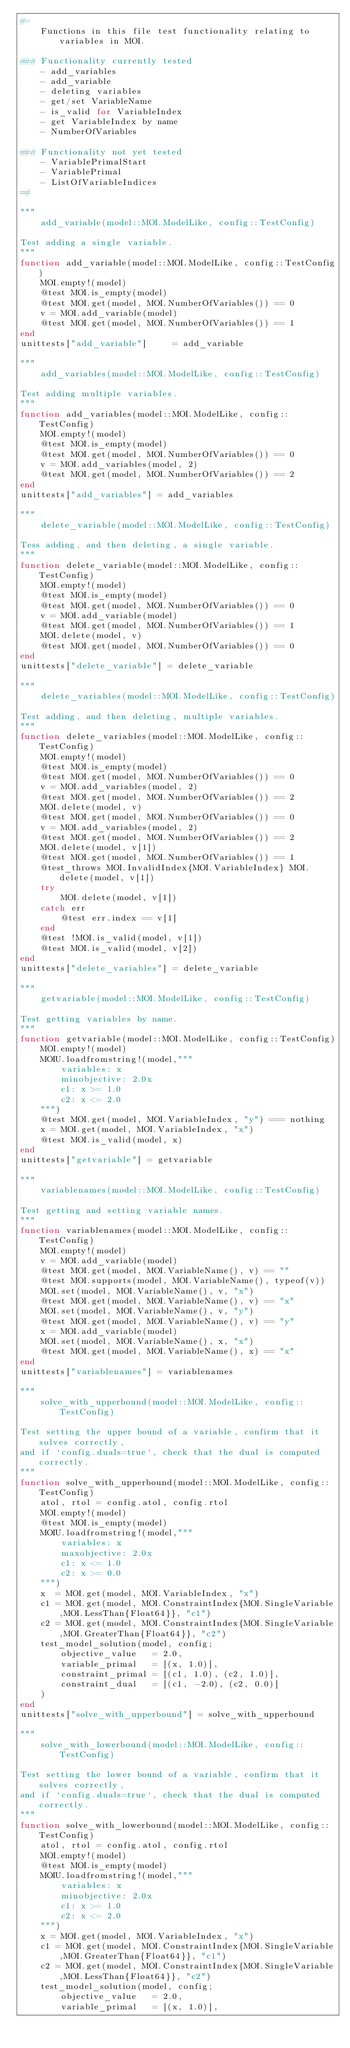Convert code to text. <code><loc_0><loc_0><loc_500><loc_500><_Julia_>#=
    Functions in this file test functionality relating to variables in MOI.

### Functionality currently tested
    - add_variables
    - add_variable
    - deleting variables
    - get/set VariableName
    - is_valid for VariableIndex
    - get VariableIndex by name
    - NumberOfVariables

### Functionality not yet tested
    - VariablePrimalStart
    - VariablePrimal
    - ListOfVariableIndices
=#

"""
    add_variable(model::MOI.ModelLike, config::TestConfig)

Test adding a single variable.
"""
function add_variable(model::MOI.ModelLike, config::TestConfig)
    MOI.empty!(model)
    @test MOI.is_empty(model)
    @test MOI.get(model, MOI.NumberOfVariables()) == 0
    v = MOI.add_variable(model)
    @test MOI.get(model, MOI.NumberOfVariables()) == 1
end
unittests["add_variable"]     = add_variable

"""
    add_variables(model::MOI.ModelLike, config::TestConfig)

Test adding multiple variables.
"""
function add_variables(model::MOI.ModelLike, config::TestConfig)
    MOI.empty!(model)
    @test MOI.is_empty(model)
    @test MOI.get(model, MOI.NumberOfVariables()) == 0
    v = MOI.add_variables(model, 2)
    @test MOI.get(model, MOI.NumberOfVariables()) == 2
end
unittests["add_variables"] = add_variables

"""
    delete_variable(model::MOI.ModelLike, config::TestConfig)

Tess adding, and then deleting, a single variable.
"""
function delete_variable(model::MOI.ModelLike, config::TestConfig)
    MOI.empty!(model)
    @test MOI.is_empty(model)
    @test MOI.get(model, MOI.NumberOfVariables()) == 0
    v = MOI.add_variable(model)
    @test MOI.get(model, MOI.NumberOfVariables()) == 1
    MOI.delete(model, v)
    @test MOI.get(model, MOI.NumberOfVariables()) == 0
end
unittests["delete_variable"] = delete_variable

"""
    delete_variables(model::MOI.ModelLike, config::TestConfig)

Test adding, and then deleting, multiple variables.
"""
function delete_variables(model::MOI.ModelLike, config::TestConfig)
    MOI.empty!(model)
    @test MOI.is_empty(model)
    @test MOI.get(model, MOI.NumberOfVariables()) == 0
    v = MOI.add_variables(model, 2)
    @test MOI.get(model, MOI.NumberOfVariables()) == 2
    MOI.delete(model, v)
    @test MOI.get(model, MOI.NumberOfVariables()) == 0
    v = MOI.add_variables(model, 2)
    @test MOI.get(model, MOI.NumberOfVariables()) == 2
    MOI.delete(model, v[1])
    @test MOI.get(model, MOI.NumberOfVariables()) == 1
    @test_throws MOI.InvalidIndex{MOI.VariableIndex} MOI.delete(model, v[1])
    try
        MOI.delete(model, v[1])
    catch err
        @test err.index == v[1]
    end
    @test !MOI.is_valid(model, v[1])
    @test MOI.is_valid(model, v[2])
end
unittests["delete_variables"] = delete_variable

"""
    getvariable(model::MOI.ModelLike, config::TestConfig)

Test getting variables by name.
"""
function getvariable(model::MOI.ModelLike, config::TestConfig)
    MOI.empty!(model)
    MOIU.loadfromstring!(model,"""
        variables: x
        minobjective: 2.0x
        c1: x >= 1.0
        c2: x <= 2.0
    """)
    @test MOI.get(model, MOI.VariableIndex, "y") === nothing
    x = MOI.get(model, MOI.VariableIndex, "x")
    @test MOI.is_valid(model, x)
end
unittests["getvariable"] = getvariable

"""
    variablenames(model::MOI.ModelLike, config::TestConfig)

Test getting and setting variable names.
"""
function variablenames(model::MOI.ModelLike, config::TestConfig)
    MOI.empty!(model)
    v = MOI.add_variable(model)
    @test MOI.get(model, MOI.VariableName(), v) == ""
    @test MOI.supports(model, MOI.VariableName(), typeof(v))
    MOI.set(model, MOI.VariableName(), v, "x")
    @test MOI.get(model, MOI.VariableName(), v) == "x"
    MOI.set(model, MOI.VariableName(), v, "y")
    @test MOI.get(model, MOI.VariableName(), v) == "y"
    x = MOI.add_variable(model)
    MOI.set(model, MOI.VariableName(), x, "x")
    @test MOI.get(model, MOI.VariableName(), x) == "x"
end
unittests["variablenames"] = variablenames

"""
    solve_with_upperbound(model::MOI.ModelLike, config::TestConfig)

Test setting the upper bound of a variable, confirm that it solves correctly,
and if `config.duals=true`, check that the dual is computed correctly.
"""
function solve_with_upperbound(model::MOI.ModelLike, config::TestConfig)
    atol, rtol = config.atol, config.rtol
    MOI.empty!(model)
    @test MOI.is_empty(model)
    MOIU.loadfromstring!(model,"""
        variables: x
        maxobjective: 2.0x
        c1: x <= 1.0
        c2: x >= 0.0
    """)
    x  = MOI.get(model, MOI.VariableIndex, "x")
    c1 = MOI.get(model, MOI.ConstraintIndex{MOI.SingleVariable,MOI.LessThan{Float64}}, "c1")
    c2 = MOI.get(model, MOI.ConstraintIndex{MOI.SingleVariable,MOI.GreaterThan{Float64}}, "c2")
    test_model_solution(model, config;
        objective_value   = 2.0,
        variable_primal   = [(x, 1.0)],
        constraint_primal = [(c1, 1.0), (c2, 1.0)],
        constraint_dual   = [(c1, -2.0), (c2, 0.0)]
    )
end
unittests["solve_with_upperbound"] = solve_with_upperbound

"""
    solve_with_lowerbound(model::MOI.ModelLike, config::TestConfig)

Test setting the lower bound of a variable, confirm that it solves correctly,
and if `config.duals=true`, check that the dual is computed correctly.
"""
function solve_with_lowerbound(model::MOI.ModelLike, config::TestConfig)
    atol, rtol = config.atol, config.rtol
    MOI.empty!(model)
    @test MOI.is_empty(model)
    MOIU.loadfromstring!(model,"""
        variables: x
        minobjective: 2.0x
        c1: x >= 1.0
        c2: x <= 2.0
    """)
    x = MOI.get(model, MOI.VariableIndex, "x")
    c1 = MOI.get(model, MOI.ConstraintIndex{MOI.SingleVariable,MOI.GreaterThan{Float64}}, "c1")
    c2 = MOI.get(model, MOI.ConstraintIndex{MOI.SingleVariable,MOI.LessThan{Float64}}, "c2")
    test_model_solution(model, config;
        objective_value   = 2.0,
        variable_primal   = [(x, 1.0)],</code> 